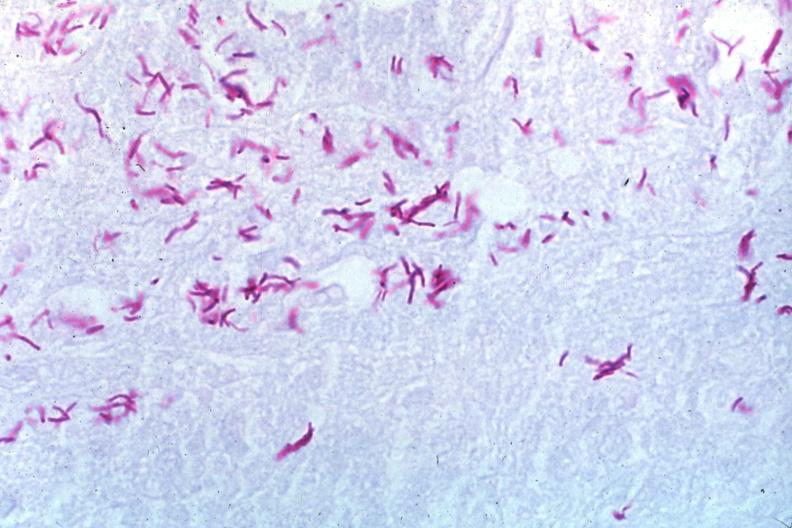what is present?
Answer the question using a single word or phrase. Tuberculosis 